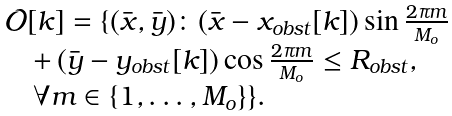Convert formula to latex. <formula><loc_0><loc_0><loc_500><loc_500>\begin{array} { l } \mathcal { O } [ k ] = \{ ( \bar { x } , \bar { y } ) \colon ( \bar { x } - x _ { o b s t } [ k ] ) \sin \frac { 2 \pi m } { M _ { o } } \\ \quad + \, ( \bar { y } - y _ { o b s t } [ k ] ) \cos \frac { 2 \pi m } { M _ { o } } \leq R _ { o b s t } , \\ \quad \forall m \in \{ 1 , \dots , M _ { o } \} \} . \end{array}</formula> 